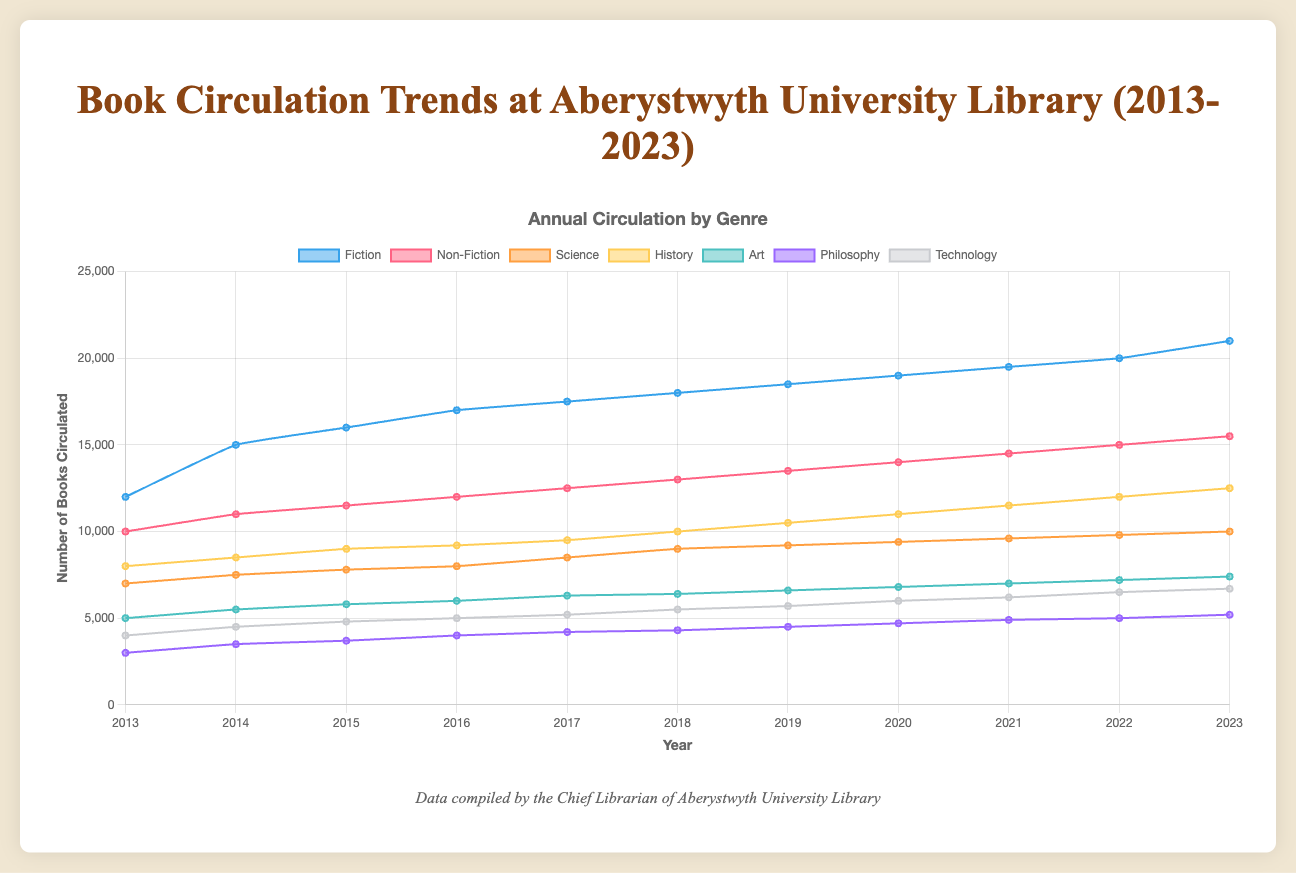Which genre had the highest circulation in 2023? To find the highest circulation in 2023, look at the data points for all genres in 2023 and identify the genre with the maximum value. Fiction had 21000, Non-Fiction had 15500, Science had 10000, History had 12500, Art had 7400, Philosophy had 5200, and Technology had 6700.
Answer: Fiction By how much did the circulation of Non-Fiction books increase from 2013 to 2023? Subtract the circulation in 2013 from that in 2023. Non-Fiction had 10000 circulations in 2013 and 15500 in 2023. The increase is 15500 - 10000.
Answer: 5500 Which genre saw the smallest increase in circulation from 2013 to 2023? To find the smallest increase, calculate the difference for each genre between 2013 and 2023 and compare. Fiction increased by 9000 (21000 - 12000), Non-Fiction by 5500 (15500 - 10000), Science by 3000 (10000 - 7000), History by 4500 (12500 - 8000), Art by 2400 (7400 - 5000), Philosophy by 2200 (5200 - 3000), and Technology by 2700 (6700 - 4000).
Answer: Philosophy In which year did Fiction books first surpass 15000 circulations? Review the annual data points for the Fiction genre and identify the first year where the value exceeds 15000. Fiction surpasses 15000 circulations in 2014 with 15000 circulations.
Answer: 2014 What is the total circulation of all genres combined in 2020? Sum the circulations of all genres in 2020. Fiction had 19000, Non-Fiction 14000, Science 9400, History 11000, Art 6800, Philosophy 4700, and Technology 6000. The total is 19000 + 14000 + 9400 + 11000 + 6800 + 4700 + 6000.
Answer: 69900 Which genre had the most consistent circulation (least variation) over the decade? Consistency can be identified by the smallest range between the highest and lowest circulations. Calculate the range for each genre. Fiction ranged 12000-21000, Non-Fiction 10000-15500, Science 7000-10000, History 8000-12500, Art 5000-7400, Philosophy 3000-5200, and Technology 4000-6700.
Answer: Science How did the circulation of Science books in 2018 compare to that in 2013? Compare the values for Science in 2018 and 2013. Science had 9000 circulations in 2018 and 7000 in 2013.
Answer: Increased by 2000 What is the average annual circulation for History books from 2013 to 2023? Calculate the total circulation for History books over the 11 years and divide by 11. The yearly circulations are 8000, 8500, 9000, 9200, 9500, 10000, 10500, 11000, 11500, 12000, and 12500. Sum these values and divide by 11. (8000 + 8500 + 9000 + 9200 + 9500 + 10000 + 10500 + 11000 + 11500 + 12000 + 12500) / 11.
Answer: 10500 